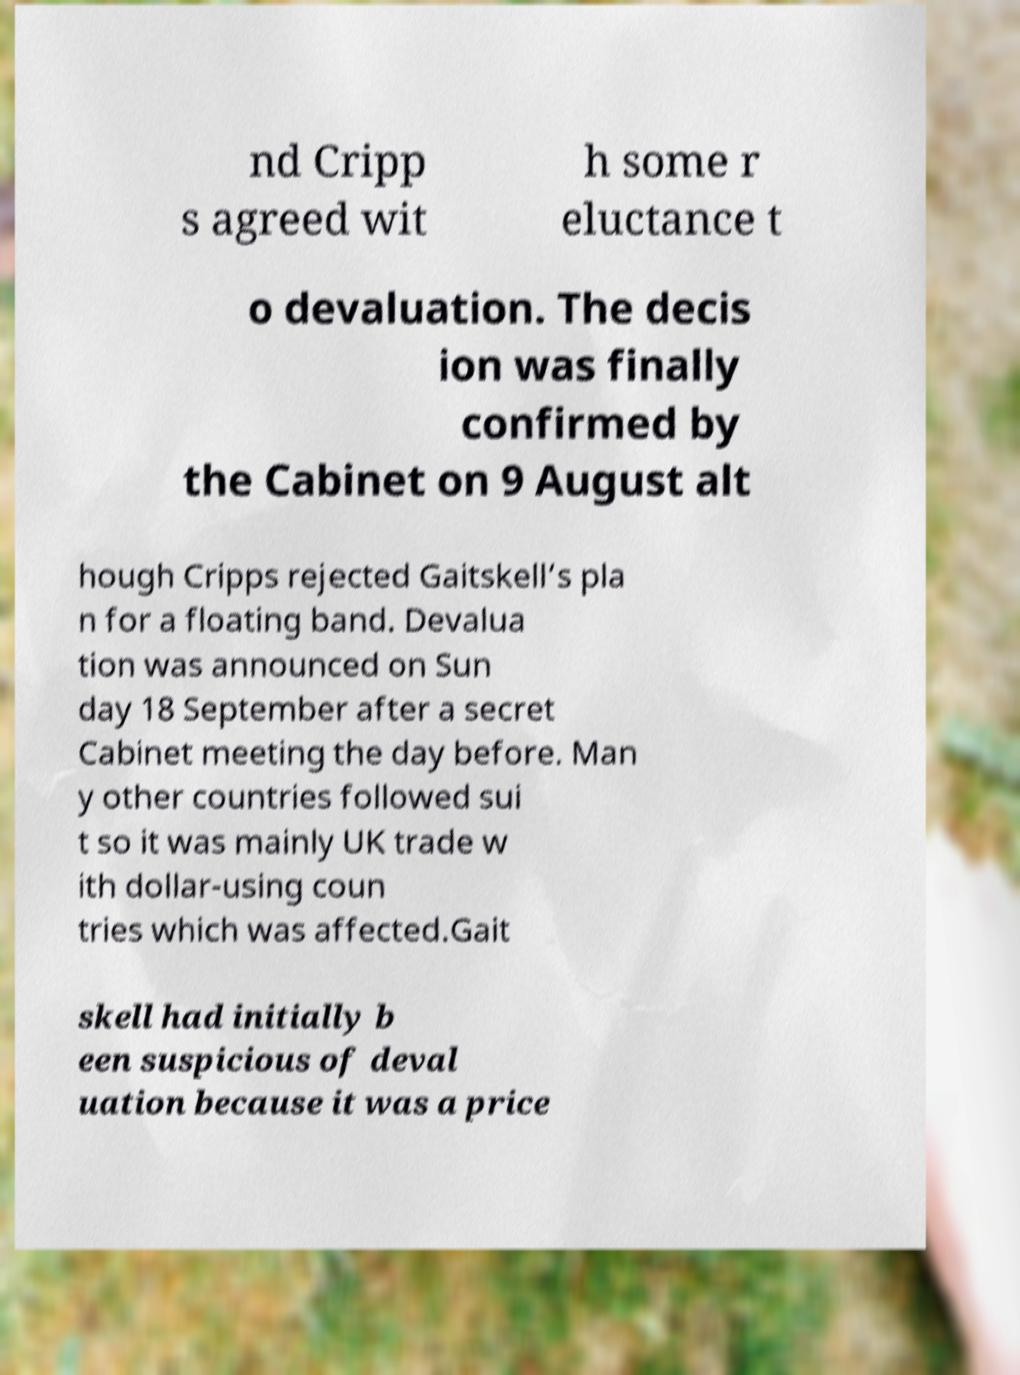I need the written content from this picture converted into text. Can you do that? nd Cripp s agreed wit h some r eluctance t o devaluation. The decis ion was finally confirmed by the Cabinet on 9 August alt hough Cripps rejected Gaitskell’s pla n for a floating band. Devalua tion was announced on Sun day 18 September after a secret Cabinet meeting the day before. Man y other countries followed sui t so it was mainly UK trade w ith dollar-using coun tries which was affected.Gait skell had initially b een suspicious of deval uation because it was a price 